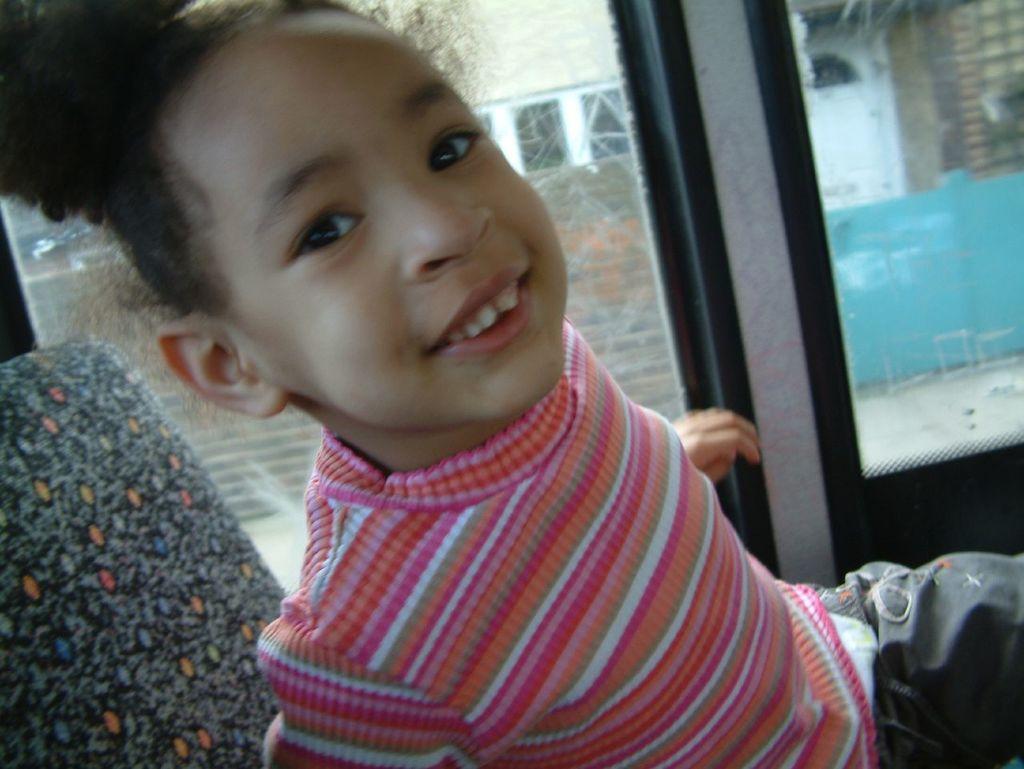In one or two sentences, can you explain what this image depicts? In this image there is a kid sitting on a chair in the background there is a glass window. 